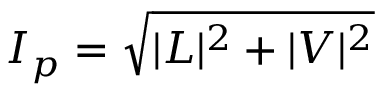Convert formula to latex. <formula><loc_0><loc_0><loc_500><loc_500>I _ { p } = { \sqrt { | L | ^ { 2 } + | V | ^ { 2 } } }</formula> 